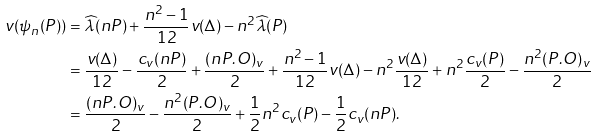<formula> <loc_0><loc_0><loc_500><loc_500>v ( \psi _ { n } ( P ) ) & = \widehat { \lambda } ( n P ) + \frac { n ^ { 2 } - 1 } { 1 2 } v ( \Delta ) - n ^ { 2 } \widehat { \lambda } ( P ) \\ & = \frac { v ( \Delta ) } { 1 2 } - \frac { c _ { v } ( n P ) } 2 + \frac { ( n P . O ) _ { v } } 2 + \frac { n ^ { 2 } - 1 } { 1 2 } v ( \Delta ) - n ^ { 2 } \frac { v ( \Delta ) } { 1 2 } + n ^ { 2 } \frac { c _ { v } ( P ) } 2 - \frac { n ^ { 2 } ( P . O ) _ { v } } 2 \\ & = \frac { ( n P . O ) _ { v } } 2 - \frac { n ^ { 2 } ( P . O ) _ { v } } 2 + \frac { 1 } { 2 } n ^ { 2 } c _ { v } ( P ) - \frac { 1 } { 2 } c _ { v } ( n P ) .</formula> 